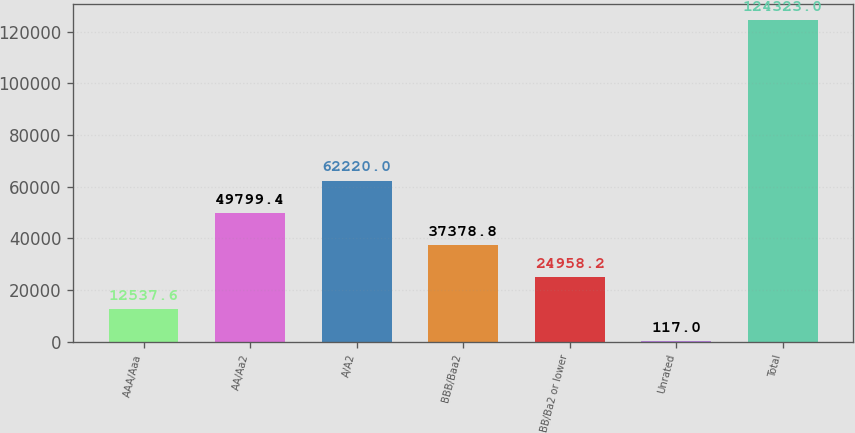Convert chart. <chart><loc_0><loc_0><loc_500><loc_500><bar_chart><fcel>AAA/Aaa<fcel>AA/Aa2<fcel>A/A2<fcel>BBB/Baa2<fcel>BB/Ba2 or lower<fcel>Unrated<fcel>Total<nl><fcel>12537.6<fcel>49799.4<fcel>62220<fcel>37378.8<fcel>24958.2<fcel>117<fcel>124323<nl></chart> 